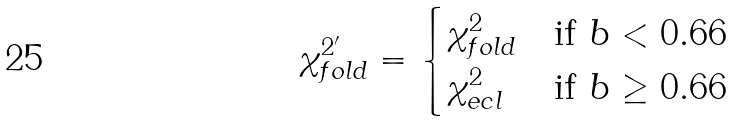Convert formula to latex. <formula><loc_0><loc_0><loc_500><loc_500>\chi ^ { 2 ^ { \prime } } _ { f o l d } = \begin{cases} \chi ^ { 2 } _ { f o l d } & \text {if $b < 0.66$} \\ \chi ^ { 2 } _ { e c l } & \text {if $b \geq 0.66$} \end{cases}</formula> 